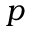Convert formula to latex. <formula><loc_0><loc_0><loc_500><loc_500>p</formula> 